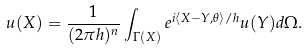Convert formula to latex. <formula><loc_0><loc_0><loc_500><loc_500>u ( X ) = \frac { 1 } { ( 2 \pi { h } ) ^ { n } } \int _ { \Gamma ( X ) } e ^ { i \langle { X - Y , \theta } \rangle / h } u ( Y ) d \Omega .</formula> 